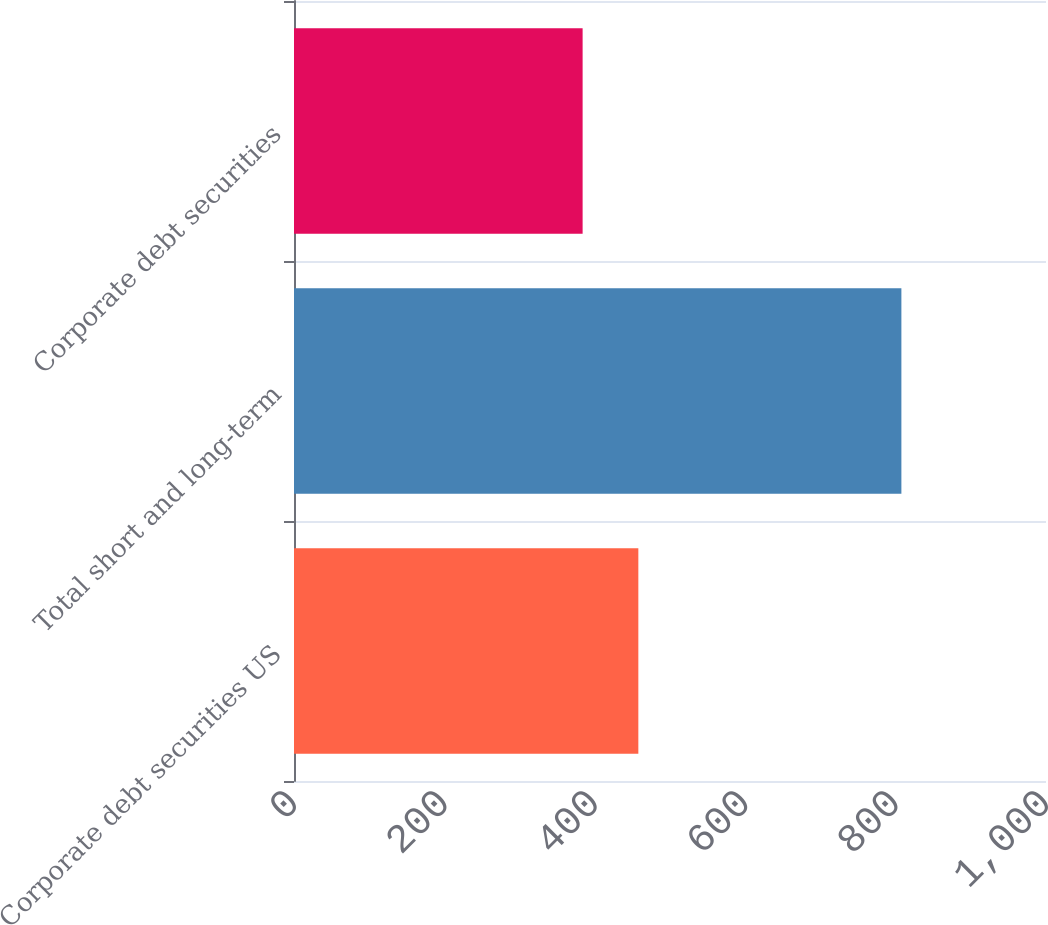Convert chart. <chart><loc_0><loc_0><loc_500><loc_500><bar_chart><fcel>Corporate debt securities US<fcel>Total short and long-term<fcel>Corporate debt securities<nl><fcel>457.9<fcel>807.7<fcel>383.8<nl></chart> 